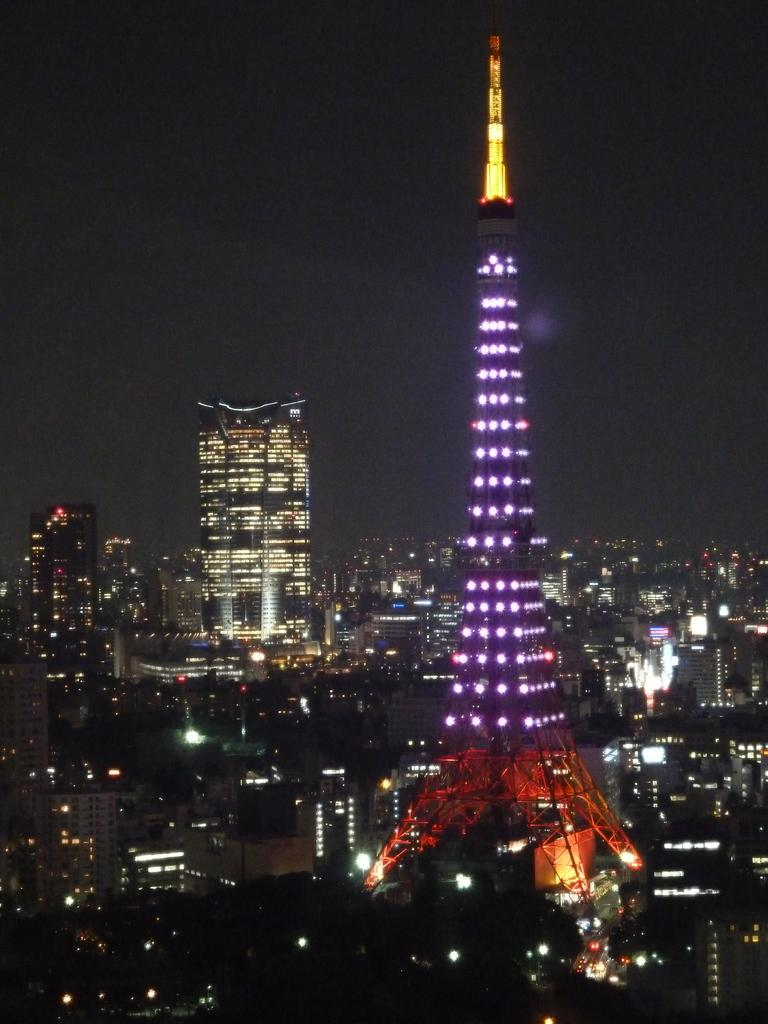What is the main structure in the image? There is a tower in the image. What other structures can be seen in the image? There are buildings in the image. What can be observed illuminating the scene in the image? There are lights visible in the image. Where is the cushion placed in the image? There is no cushion present in the image. What type of basketball game is being played in the image? There is no basketball game or any reference to a basketball in the image. 